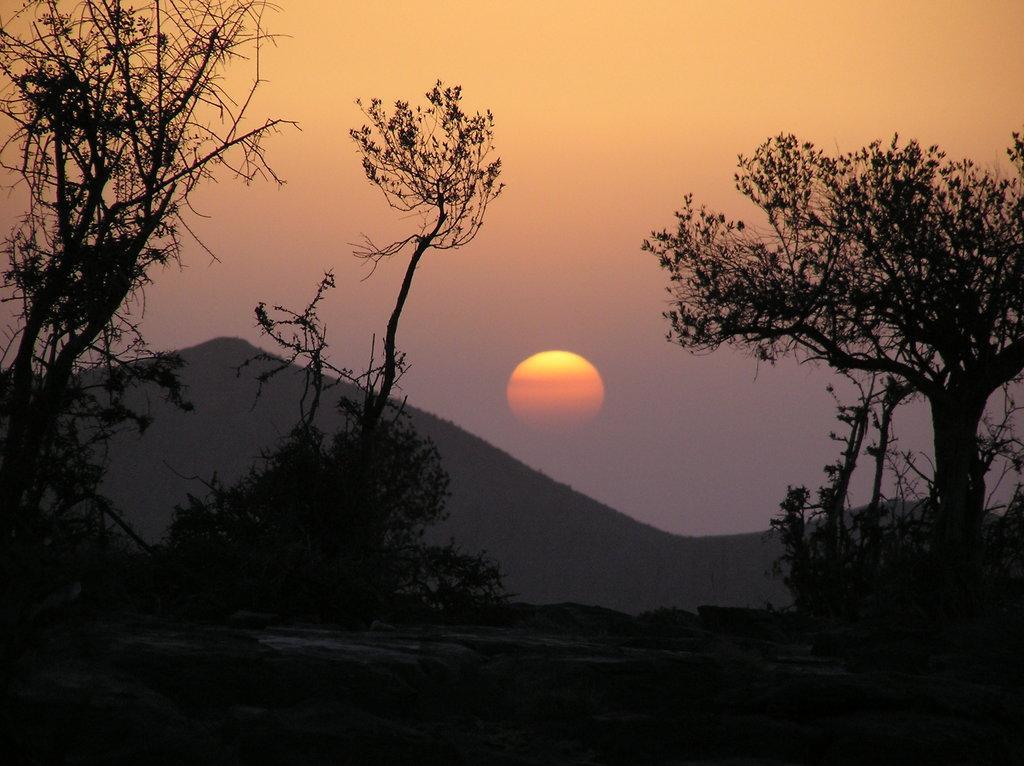Could you give a brief overview of what you see in this image? In this picture we can see the sunset view. In the front there are some trees. In the background there is an orange color sun and some mountains.  